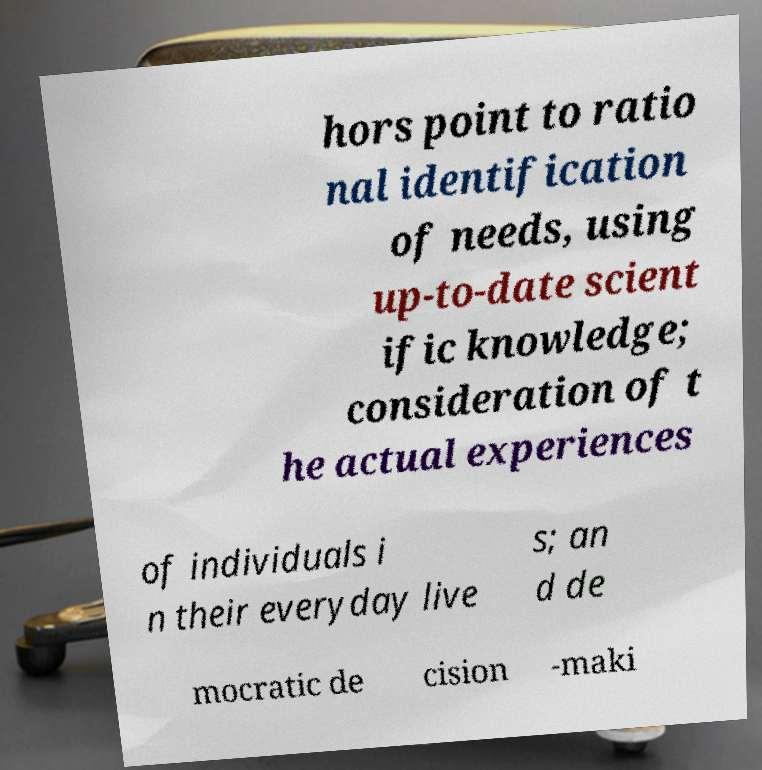Can you read and provide the text displayed in the image?This photo seems to have some interesting text. Can you extract and type it out for me? hors point to ratio nal identification of needs, using up-to-date scient ific knowledge; consideration of t he actual experiences of individuals i n their everyday live s; an d de mocratic de cision -maki 